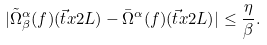Convert formula to latex. <formula><loc_0><loc_0><loc_500><loc_500>| \tilde { \Omega } ^ { \alpha } _ { \beta } ( f ) ( \vec { t } { x } { 2 } { L } ) - \bar { \Omega } ^ { \alpha } ( f ) ( \vec { t } { x } { 2 } { L } ) | \leq \frac { \eta } { \beta } .</formula> 